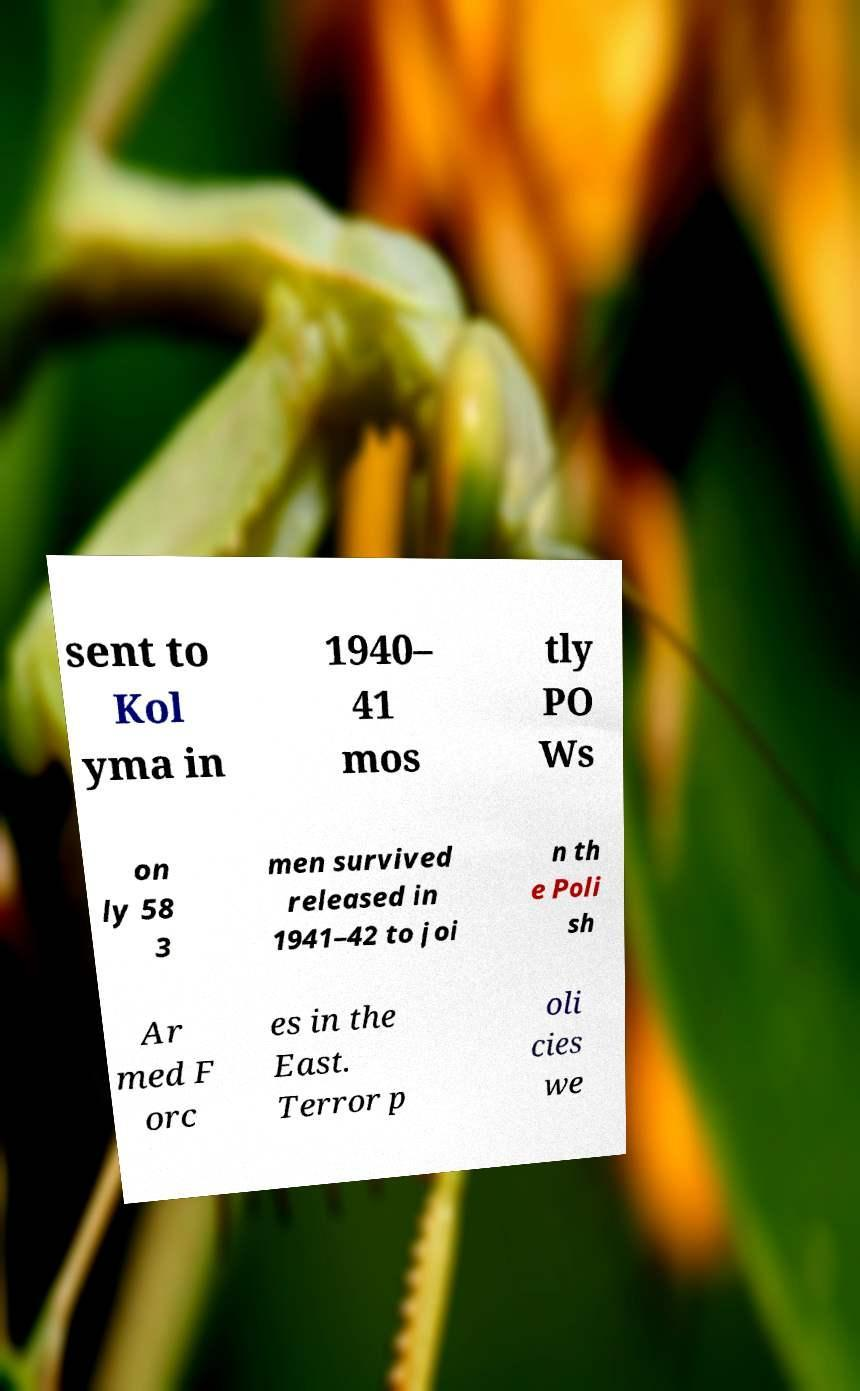What messages or text are displayed in this image? I need them in a readable, typed format. sent to Kol yma in 1940– 41 mos tly PO Ws on ly 58 3 men survived released in 1941–42 to joi n th e Poli sh Ar med F orc es in the East. Terror p oli cies we 